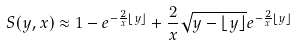<formula> <loc_0><loc_0><loc_500><loc_500>S ( y , x ) \approx 1 - e ^ { - \frac { 2 } { x } \lfloor y \rfloor } + \frac { 2 } { x } \sqrt { y - \lfloor y \rfloor } e ^ { - \frac { 2 } { x } \lfloor y \rfloor }</formula> 